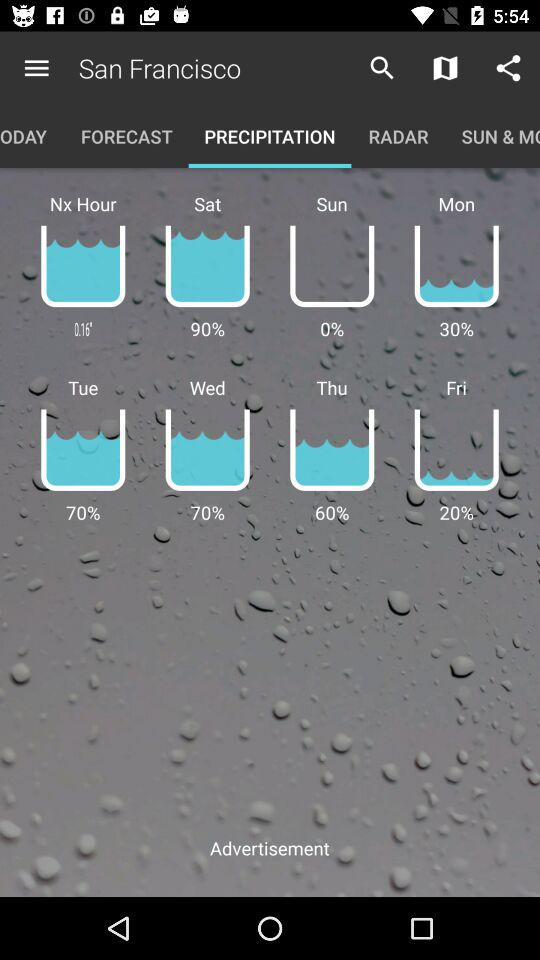What is the percentage of water on Thursday? The percentage of water on Thursday was 60. 